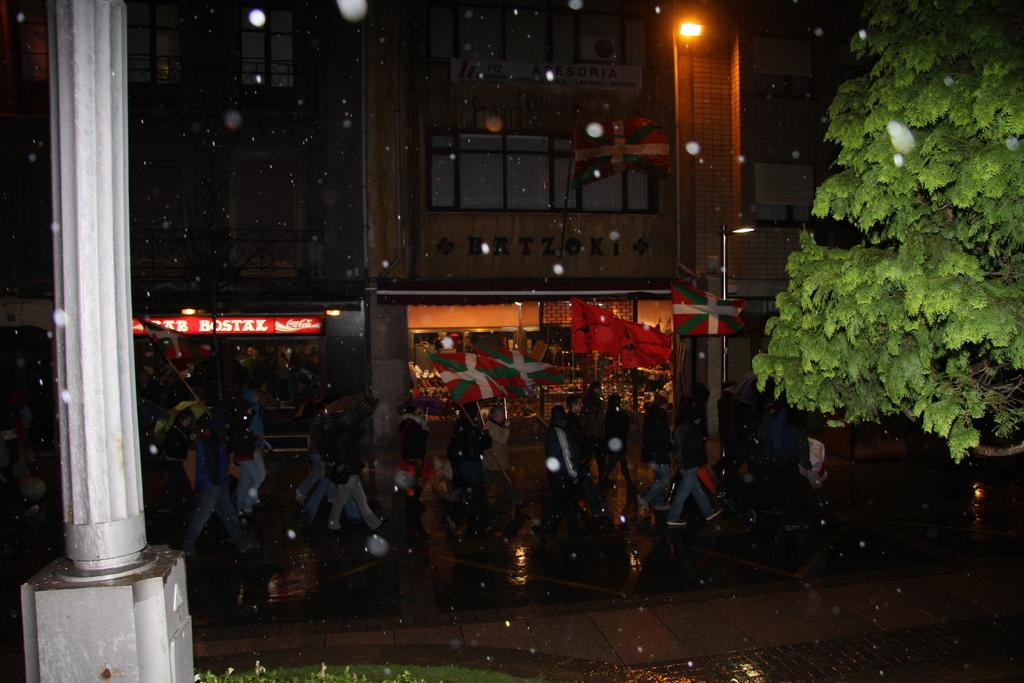What are the people in the image doing? The people in the image are walking on the road. What type of establishments can be seen in the image? There are shops visible in the image. What structures are present in the image? There are buildings in the image. What type of vegetation is present in the image? There are trees in the image. What type of lunchroom can be seen in the image? There is no lunchroom present in the image. What time of day is depicted in the image? The time of day cannot be determined from the image alone. 